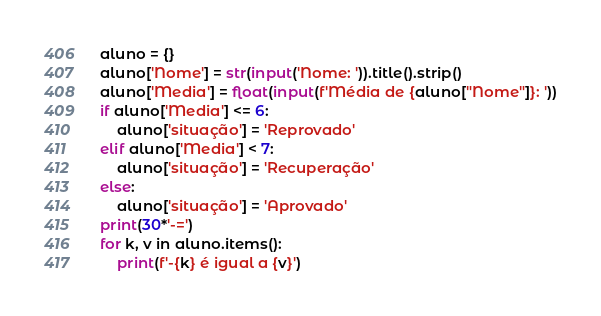Convert code to text. <code><loc_0><loc_0><loc_500><loc_500><_Python_>aluno = {}
aluno['Nome'] = str(input('Nome: ')).title().strip()
aluno['Media'] = float(input(f'Média de {aluno["Nome"]}: '))
if aluno['Media'] <= 6:
    aluno['situação'] = 'Reprovado'
elif aluno['Media'] < 7:
    aluno['situação'] = 'Recuperação'
else:
    aluno['situação'] = 'Aprovado'
print(30*'-=')
for k, v in aluno.items():
    print(f'-{k} é igual a {v}')
</code> 